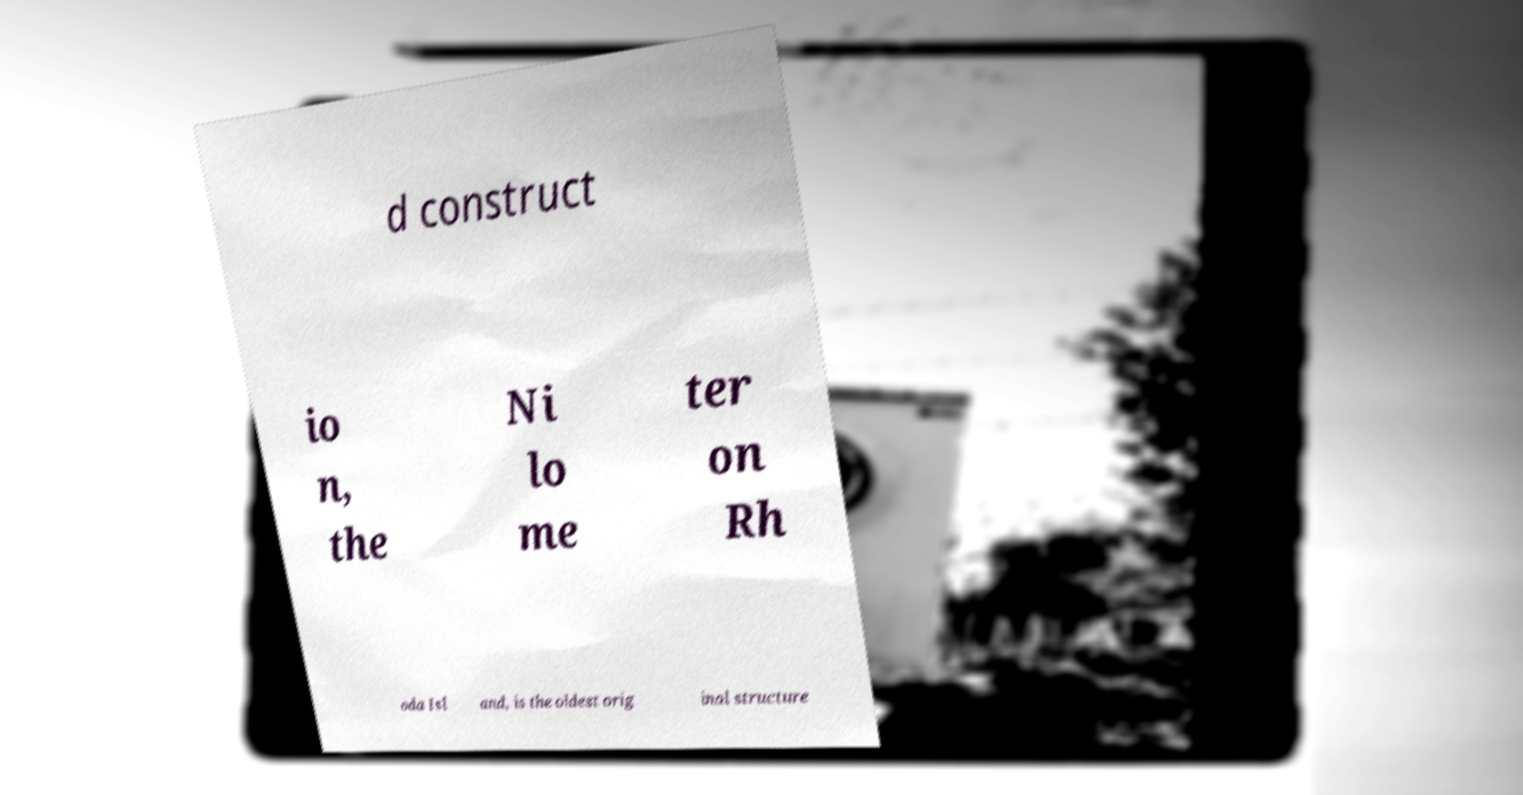Could you assist in decoding the text presented in this image and type it out clearly? d construct io n, the Ni lo me ter on Rh oda Isl and, is the oldest orig inal structure 